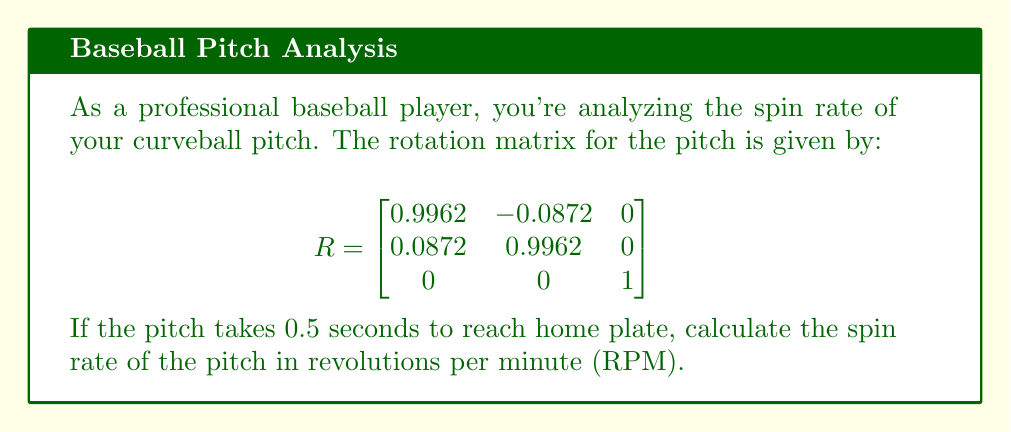Show me your answer to this math problem. To solve this problem, we'll follow these steps:

1) First, we need to find the eigenvalues of the rotation matrix. The characteristic equation is:

   $$det(R - \lambda I) = \begin{vmatrix}
   0.9962 - \lambda & -0.0872 & 0 \\
   0.0872 & 0.9962 - \lambda & 0 \\
   0 & 0 & 1 - \lambda
   \end{vmatrix} = 0$$

2) Expanding this, we get:
   
   $$(1 - \lambda)[(0.9962 - \lambda)^2 + 0.0872^2] = 0$$

3) Solving this equation, we find the eigenvalues:
   
   $\lambda_1 = 1$
   $\lambda_2 = 0.9962 + 0.0872i$
   $\lambda_3 = 0.9962 - 0.0872i$

4) The complex eigenvalues $\lambda_2$ and $\lambda_3$ represent the rotation. We can write them in the form $e^{i\theta}$:

   $$e^{i\theta} = \cos\theta + i\sin\theta = 0.9962 + 0.0872i$$

5) From this, we can find $\theta$:

   $$\theta = \arctan(\frac{0.0872}{0.9962}) \approx 0.0873 \text{ radians}$$

6) This $\theta$ represents the angle of rotation for one time step. Given that the pitch takes 0.5 seconds, the angular velocity $\omega$ is:

   $$\omega = \frac{\theta}{0.5} = 0.1746 \text{ radians/second}$$

7) To convert this to RPM, we use the formula:

   $$RPM = \frac{\omega}{2\pi} \times 60$$

8) Substituting our value for $\omega$:

   $$RPM = \frac{0.1746}{2\pi} \times 60 \approx 1668$$

Therefore, the spin rate of the pitch is approximately 1668 RPM.
Answer: 1668 RPM 